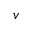Convert formula to latex. <formula><loc_0><loc_0><loc_500><loc_500>v</formula> 